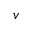Convert formula to latex. <formula><loc_0><loc_0><loc_500><loc_500>v</formula> 